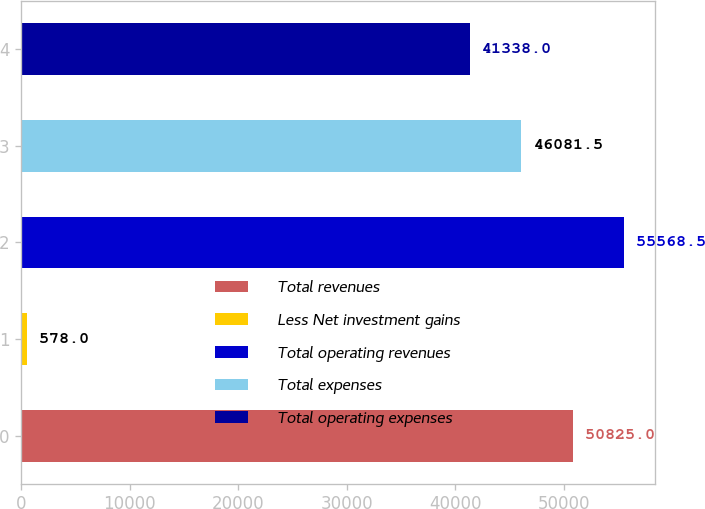Convert chart to OTSL. <chart><loc_0><loc_0><loc_500><loc_500><bar_chart><fcel>Total revenues<fcel>Less Net investment gains<fcel>Total operating revenues<fcel>Total expenses<fcel>Total operating expenses<nl><fcel>50825<fcel>578<fcel>55568.5<fcel>46081.5<fcel>41338<nl></chart> 